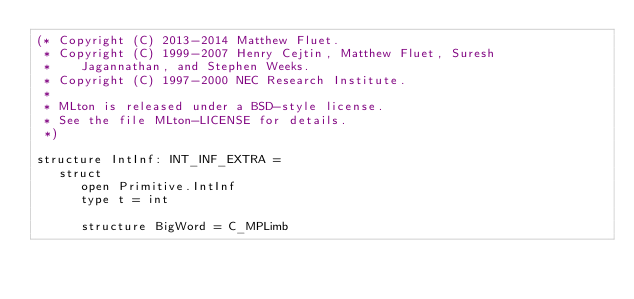<code> <loc_0><loc_0><loc_500><loc_500><_SML_>(* Copyright (C) 2013-2014 Matthew Fluet.
 * Copyright (C) 1999-2007 Henry Cejtin, Matthew Fluet, Suresh
 *    Jagannathan, and Stephen Weeks.
 * Copyright (C) 1997-2000 NEC Research Institute.
 *
 * MLton is released under a BSD-style license.
 * See the file MLton-LICENSE for details.
 *)

structure IntInf: INT_INF_EXTRA =
   struct
      open Primitive.IntInf
      type t = int

      structure BigWord = C_MPLimb</code> 